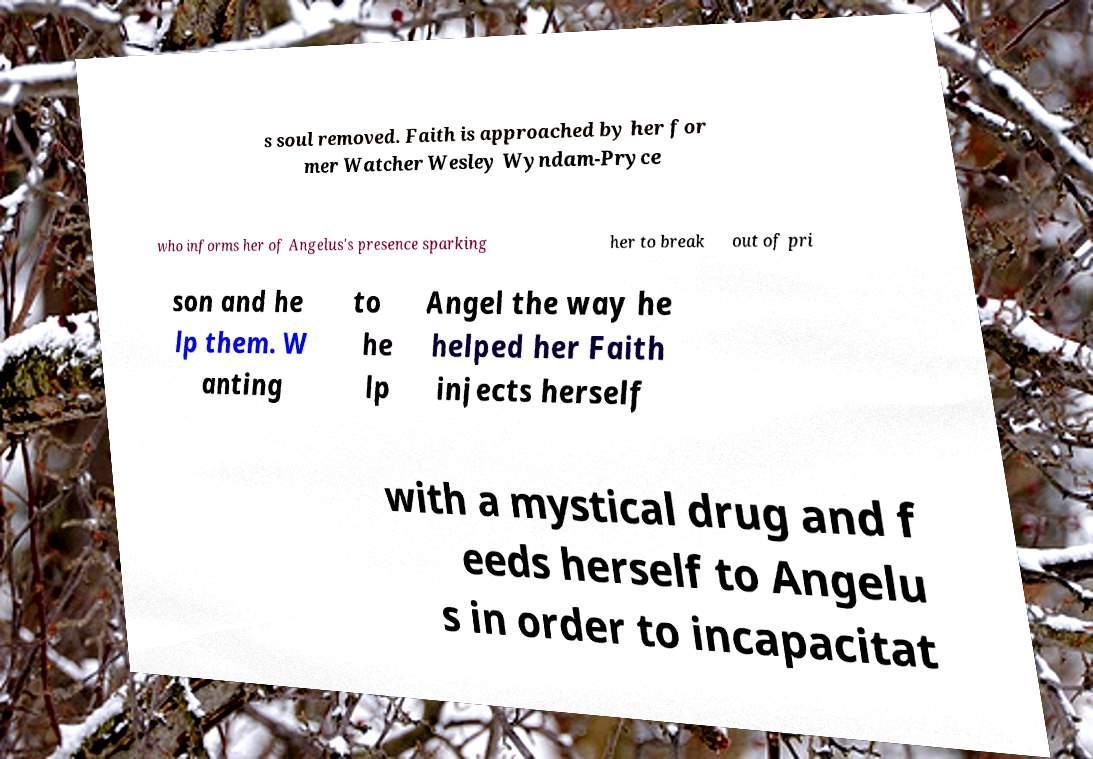Can you accurately transcribe the text from the provided image for me? s soul removed. Faith is approached by her for mer Watcher Wesley Wyndam-Pryce who informs her of Angelus's presence sparking her to break out of pri son and he lp them. W anting to he lp Angel the way he helped her Faith injects herself with a mystical drug and f eeds herself to Angelu s in order to incapacitat 